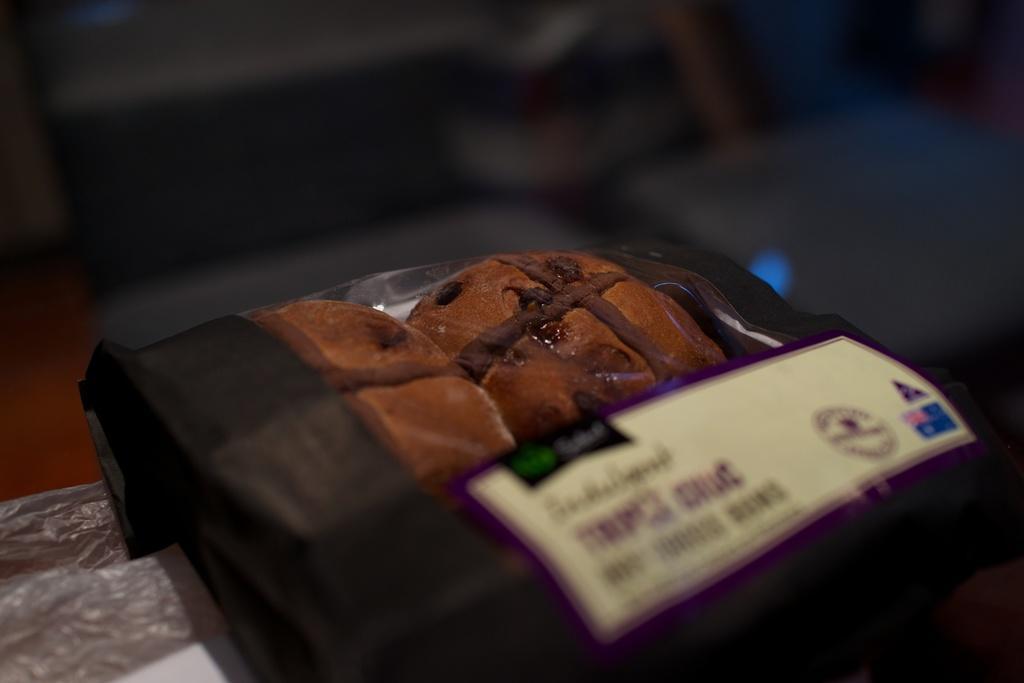How would you summarize this image in a sentence or two? In this image, we can see a food item. On the food item, we can see a paper with some text. In the background, we can see black color. On the left side, we can see a polythene cover. 